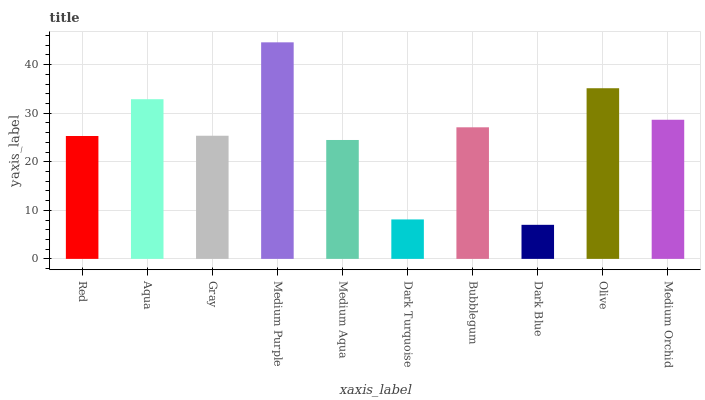Is Dark Blue the minimum?
Answer yes or no. Yes. Is Medium Purple the maximum?
Answer yes or no. Yes. Is Aqua the minimum?
Answer yes or no. No. Is Aqua the maximum?
Answer yes or no. No. Is Aqua greater than Red?
Answer yes or no. Yes. Is Red less than Aqua?
Answer yes or no. Yes. Is Red greater than Aqua?
Answer yes or no. No. Is Aqua less than Red?
Answer yes or no. No. Is Bubblegum the high median?
Answer yes or no. Yes. Is Gray the low median?
Answer yes or no. Yes. Is Aqua the high median?
Answer yes or no. No. Is Dark Blue the low median?
Answer yes or no. No. 